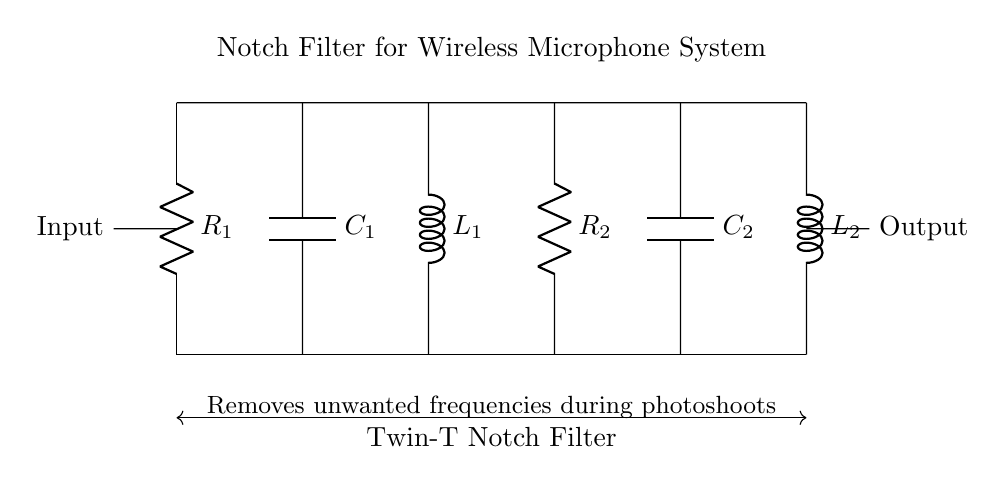What is the type of filter represented in the circuit? The circuit diagram features components arranged in a way that specifically targets and removes unwanted frequencies from a signal, indicating it is functioning as a notch filter, particularly a Twin-T Notch Filter.
Answer: Notch Filter What is the purpose of this circuit? The circuit is designed to filter out and suppress unwanted frequencies, ensuring that only the desired frequencies pass through, particularly useful in wireless microphone applications during photoshoots.
Answer: Removes unwanted frequencies How many resistors are in the circuit? By inspecting the diagram, there are two components labeled as resistors: R1 and R2, thus totaling to two resistors present in the circuit.
Answer: 2 What components are used in the filter circuit? The circuit incorporates resistors (R1, R2), capacitors (C1, C2), and inductors (L1, L2), all of which are integral to the notch filtering function, enabling the circuit to effectively target specific frequencies.
Answer: Resistors, capacitors, inductors Which component is closest to the input terminal? The input terminal connects directly to R1, identifying it as the closest component to the input side of the circuit setup shown in the diagram.
Answer: R1 What is the overall topology of the filter circuit? The arrangement of components reveals that it utilizes a combination of resistors, capacitors, and inductors in such a way to create a notch filter topology, specifically labeled here as a Twin-T configuration, which characterizes its response curve.
Answer: Twin-T 